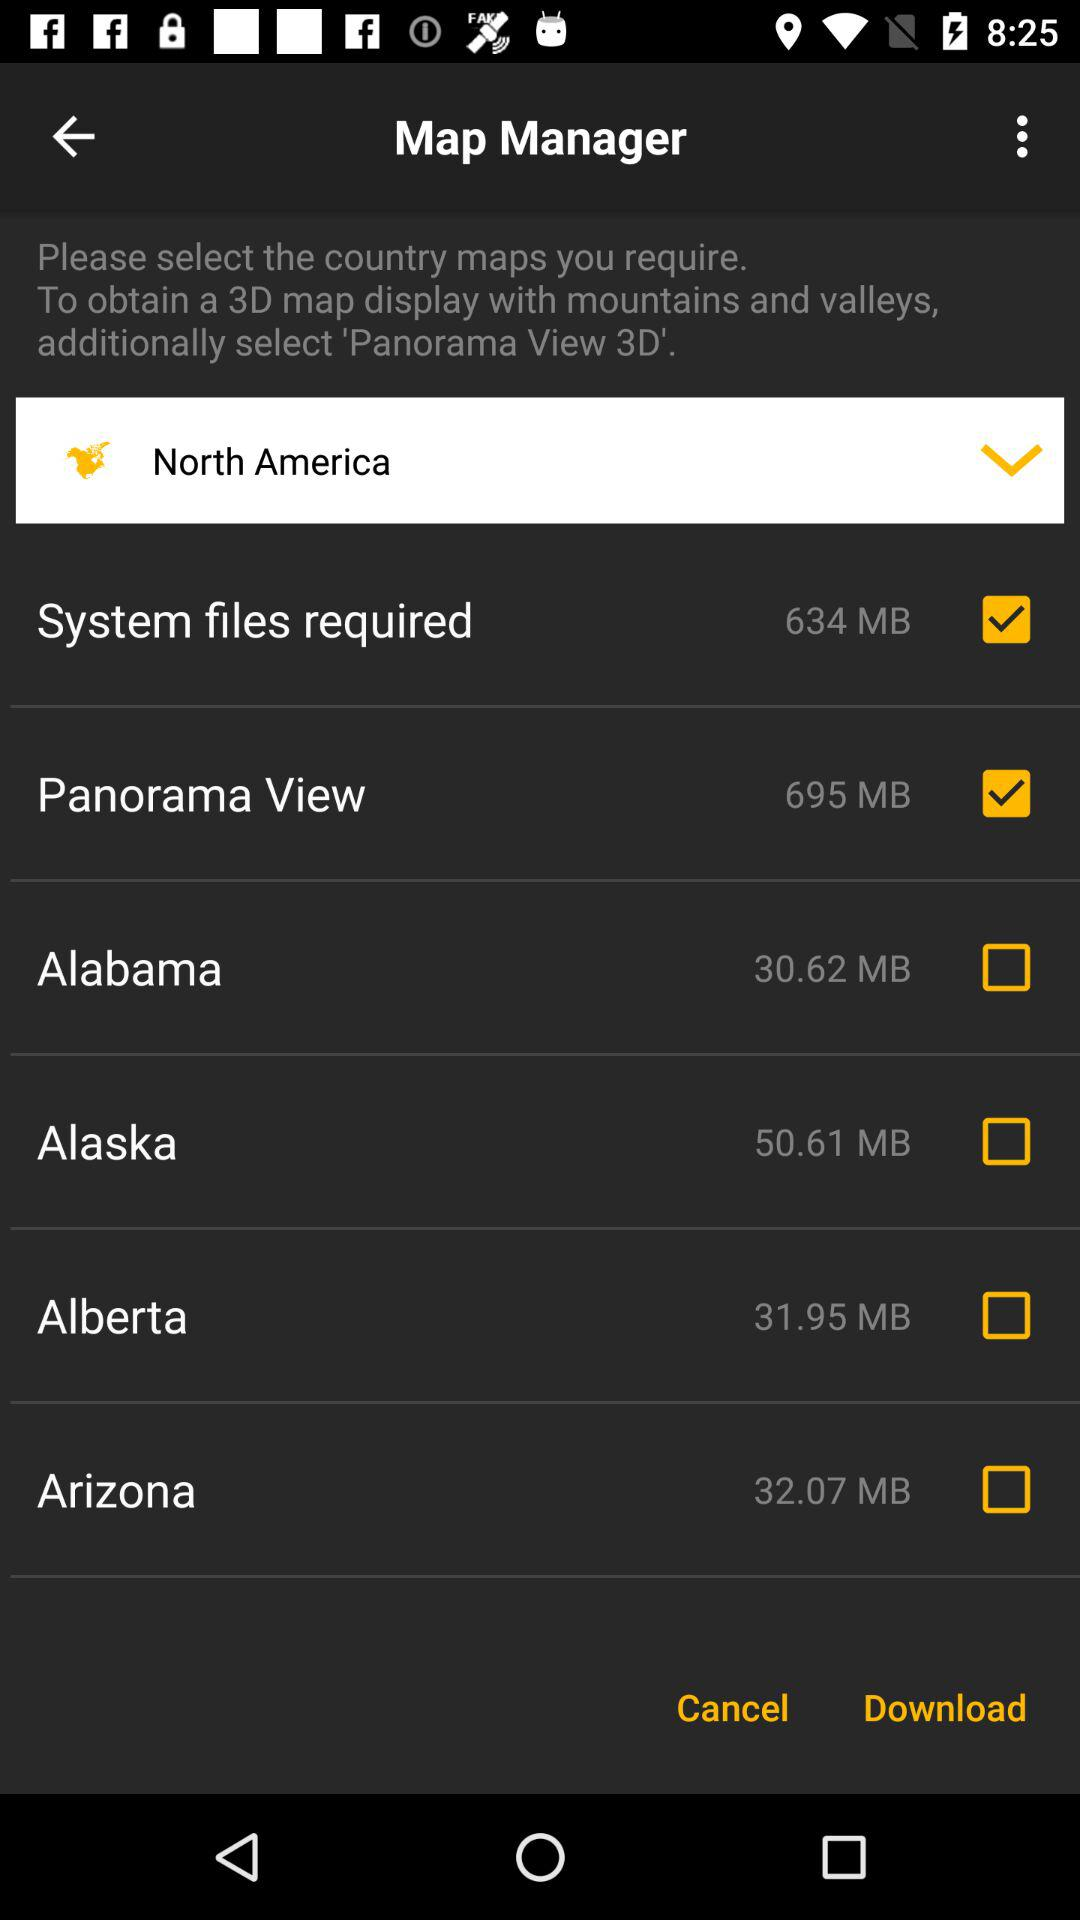How much memory will the "Alaska" file take? The "Alaska" file will take 50.61 MB of memory. 